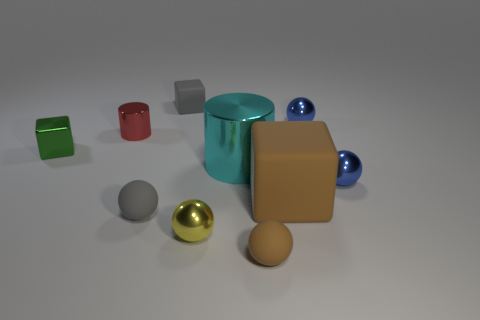Subtract all tiny brown matte balls. How many balls are left? 4 Subtract all gray spheres. How many red cylinders are left? 1 Subtract all yellow metal balls. Subtract all small brown objects. How many objects are left? 8 Add 5 big cyan metal cylinders. How many big cyan metal cylinders are left? 6 Add 9 small gray matte balls. How many small gray matte balls exist? 10 Subtract all yellow balls. How many balls are left? 4 Subtract 0 cyan cubes. How many objects are left? 10 Subtract all cubes. How many objects are left? 7 Subtract 1 cylinders. How many cylinders are left? 1 Subtract all purple blocks. Subtract all yellow balls. How many blocks are left? 3 